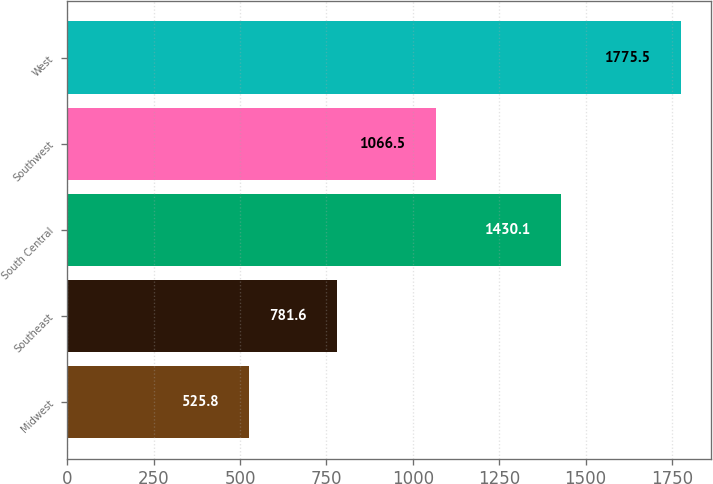<chart> <loc_0><loc_0><loc_500><loc_500><bar_chart><fcel>Midwest<fcel>Southeast<fcel>South Central<fcel>Southwest<fcel>West<nl><fcel>525.8<fcel>781.6<fcel>1430.1<fcel>1066.5<fcel>1775.5<nl></chart> 